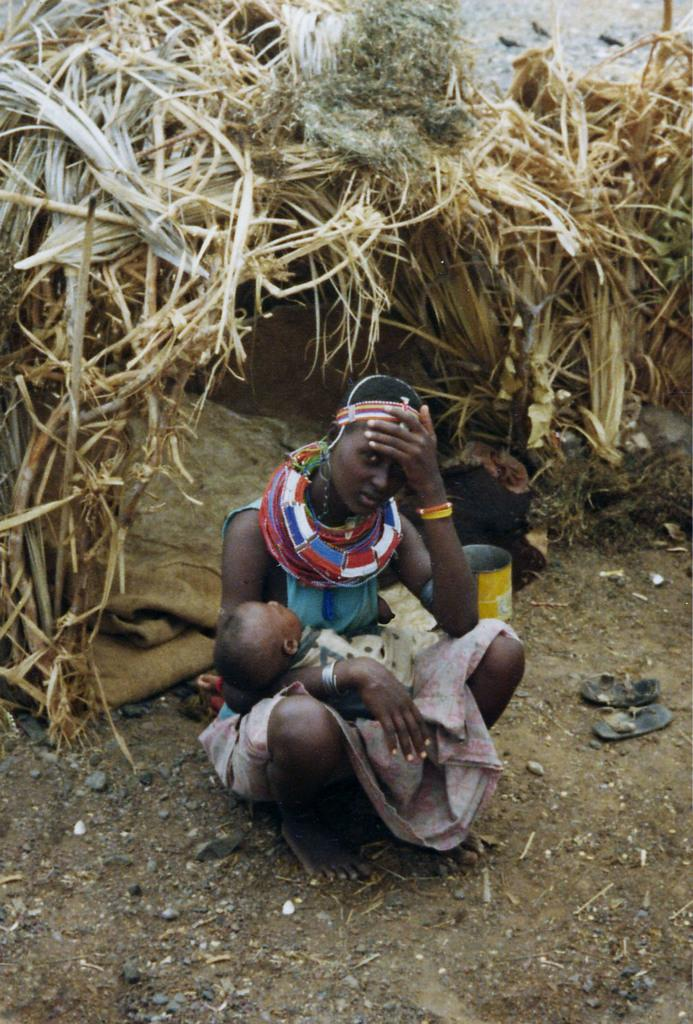What is the woman in the foreground of the image doing? The woman is sitting on the ground and holding a baby. What can be seen on the right side of the image? There are footwear on the right side of the image. What type of structure is visible in the background of the image? There is a hut in the background of the image. What type of bird can be seen in the woman's hands in the image? There is no bird visible in the woman's hands in the image. Can you tell me the total cost of the items purchased, as indicated by the receipt in the image? There is no receipt present in the image. 